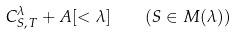<formula> <loc_0><loc_0><loc_500><loc_500>C ^ { \lambda } _ { S , \, T } + A [ < \lambda ] \quad ( S \in M ( \lambda ) )</formula> 